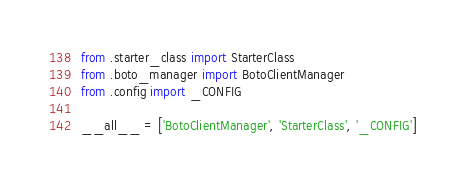Convert code to text. <code><loc_0><loc_0><loc_500><loc_500><_Python_>from .starter_class import StarterClass
from .boto_manager import BotoClientManager
from .config import _CONFIG

__all__ = ['BotoClientManager', 'StarterClass', '_CONFIG']
</code> 